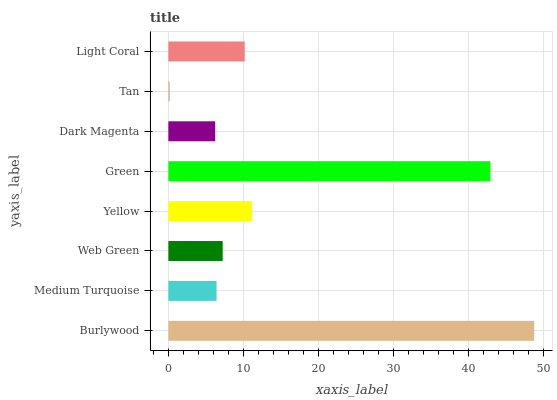Is Tan the minimum?
Answer yes or no. Yes. Is Burlywood the maximum?
Answer yes or no. Yes. Is Medium Turquoise the minimum?
Answer yes or no. No. Is Medium Turquoise the maximum?
Answer yes or no. No. Is Burlywood greater than Medium Turquoise?
Answer yes or no. Yes. Is Medium Turquoise less than Burlywood?
Answer yes or no. Yes. Is Medium Turquoise greater than Burlywood?
Answer yes or no. No. Is Burlywood less than Medium Turquoise?
Answer yes or no. No. Is Light Coral the high median?
Answer yes or no. Yes. Is Web Green the low median?
Answer yes or no. Yes. Is Burlywood the high median?
Answer yes or no. No. Is Green the low median?
Answer yes or no. No. 